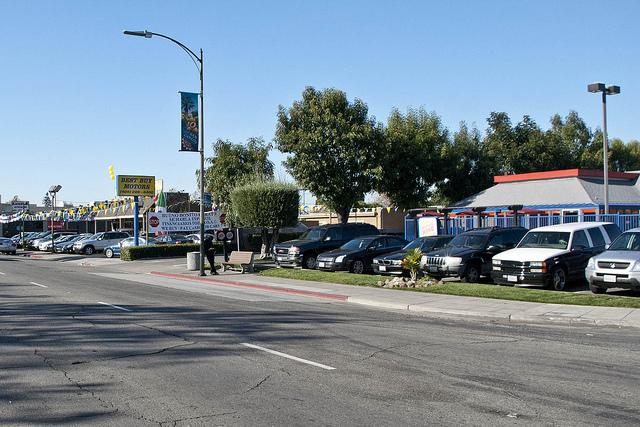What item does the business with banners in front of it sell? cars 